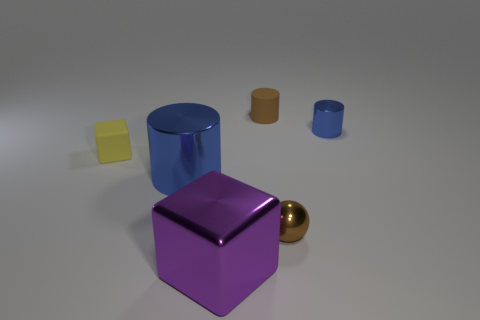What colors are present in the image, and how do they affect the composition? The image comprises a diversity of colors including blue, yellow, purple, and gold. These colors are distributed across the objects, adding contrast and visual interest to the composition, with the cool and warm tones balancing each other out. If these objects were part of a set, what might be missing? Assuming these objects are part of a geometric set, a few potential missing pieces might include other primitive shapes such as a sphere, a cone, or a pyramid to complete a more comprehensive variety of shapes. 